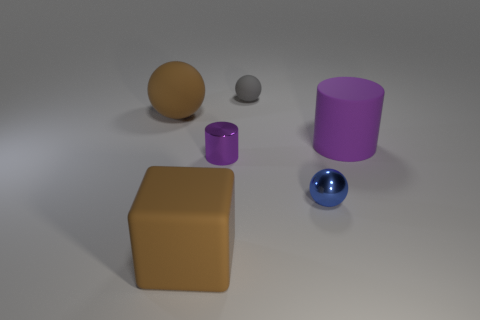Subtract all matte balls. How many balls are left? 1 Subtract 1 balls. How many balls are left? 2 Add 1 tiny purple cylinders. How many objects exist? 7 Subtract all purple balls. How many purple blocks are left? 0 Subtract all cylinders. Subtract all brown matte things. How many objects are left? 2 Add 5 purple metallic objects. How many purple metallic objects are left? 6 Add 6 green shiny cubes. How many green shiny cubes exist? 6 Subtract 0 blue cubes. How many objects are left? 6 Subtract all blocks. How many objects are left? 5 Subtract all cyan cubes. Subtract all cyan balls. How many cubes are left? 1 